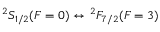<formula> <loc_0><loc_0><loc_500><loc_500>{ } ^ { 2 } S _ { 1 / 2 } ( F = 0 ) \leftrightarrow ^ { 2 } F _ { 7 / 2 } ( F = 3 )</formula> 